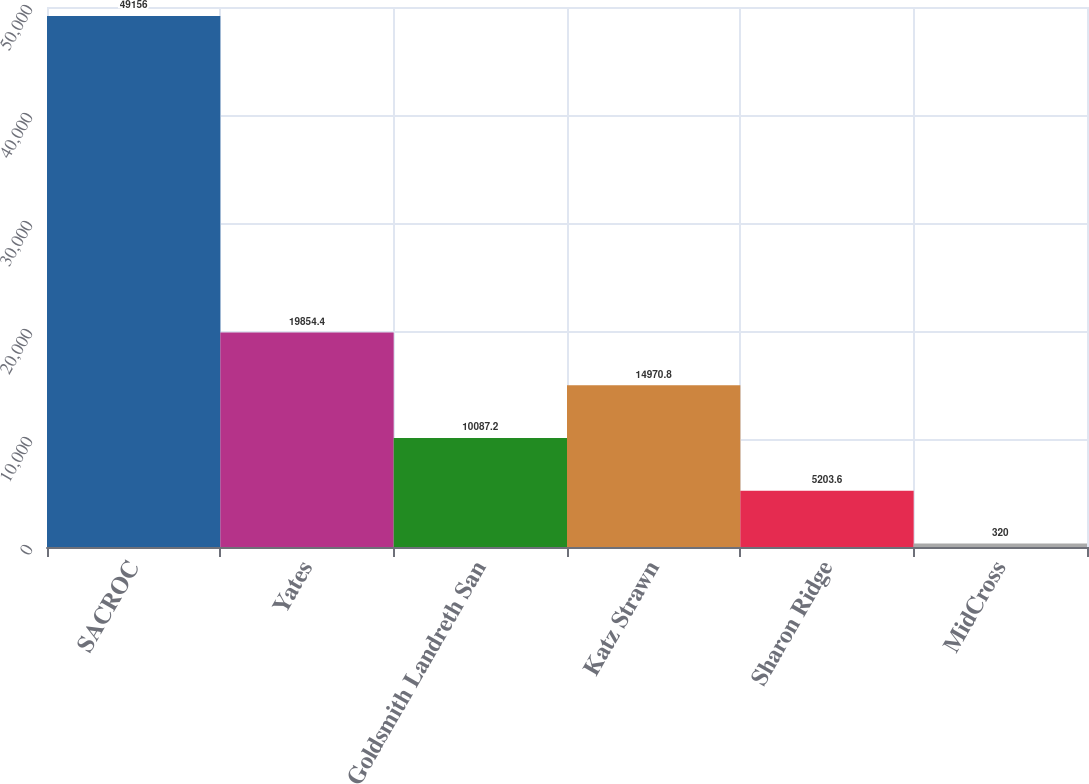Convert chart. <chart><loc_0><loc_0><loc_500><loc_500><bar_chart><fcel>SACROC<fcel>Yates<fcel>Goldsmith Landreth San<fcel>Katz Strawn<fcel>Sharon Ridge<fcel>MidCross<nl><fcel>49156<fcel>19854.4<fcel>10087.2<fcel>14970.8<fcel>5203.6<fcel>320<nl></chart> 